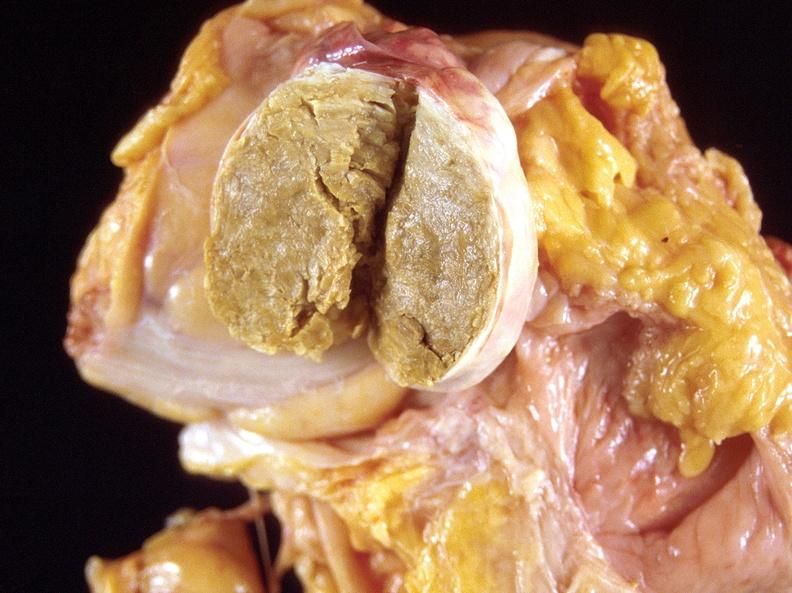what does this image show?
Answer the question using a single word or phrase. Dermoid cyst 